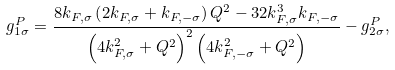<formula> <loc_0><loc_0><loc_500><loc_500>g _ { 1 \sigma } ^ { P } = \frac { 8 k _ { F , \sigma } \left ( 2 k _ { F , \sigma } + k _ { F , - \sigma } \right ) Q ^ { 2 } - 3 2 k _ { F , \sigma } ^ { 3 } k _ { F , - \sigma } } { \left ( 4 k _ { F , \sigma } ^ { 2 } + Q ^ { 2 } \right ) ^ { 2 } \left ( 4 k _ { F , - \sigma } ^ { 2 } + Q ^ { 2 } \right ) } - g _ { 2 \sigma } ^ { P } ,</formula> 